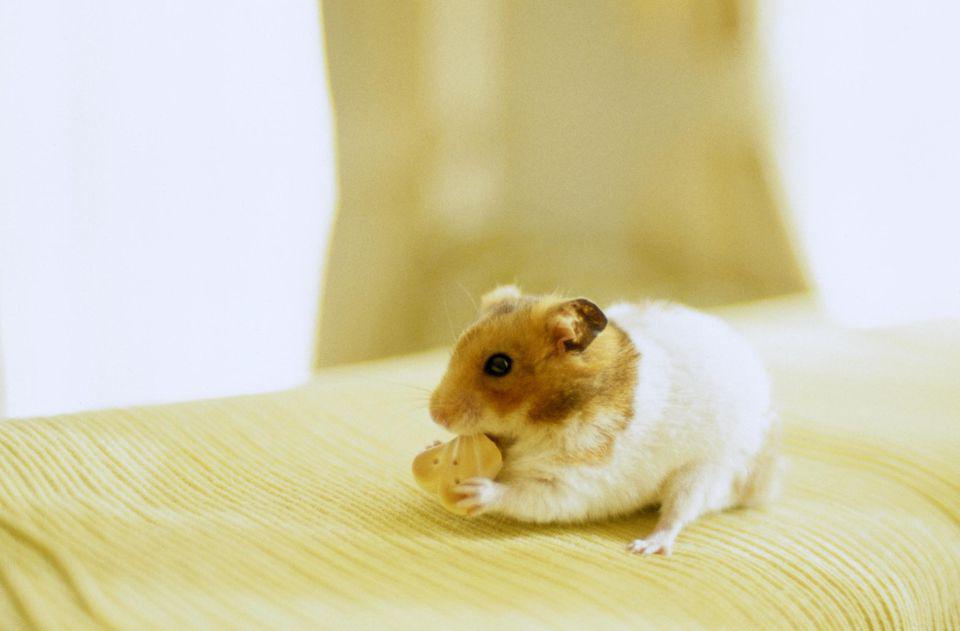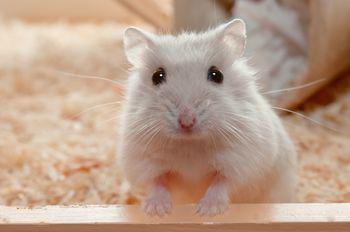The first image is the image on the left, the second image is the image on the right. Examine the images to the left and right. Is the description "The hamsters in each image appear sort of orangish, and the ones pictured by themselves also have some food they are eating." accurate? Answer yes or no. No. The first image is the image on the left, the second image is the image on the right. Assess this claim about the two images: "An image shows one hamster on the right of a round object with orange-red coloring.". Correct or not? Answer yes or no. No. 